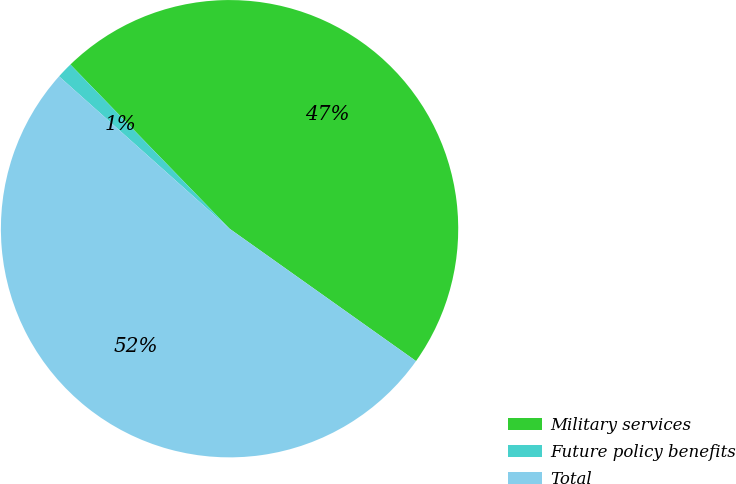Convert chart. <chart><loc_0><loc_0><loc_500><loc_500><pie_chart><fcel>Military services<fcel>Future policy benefits<fcel>Total<nl><fcel>47.08%<fcel>1.14%<fcel>51.78%<nl></chart> 